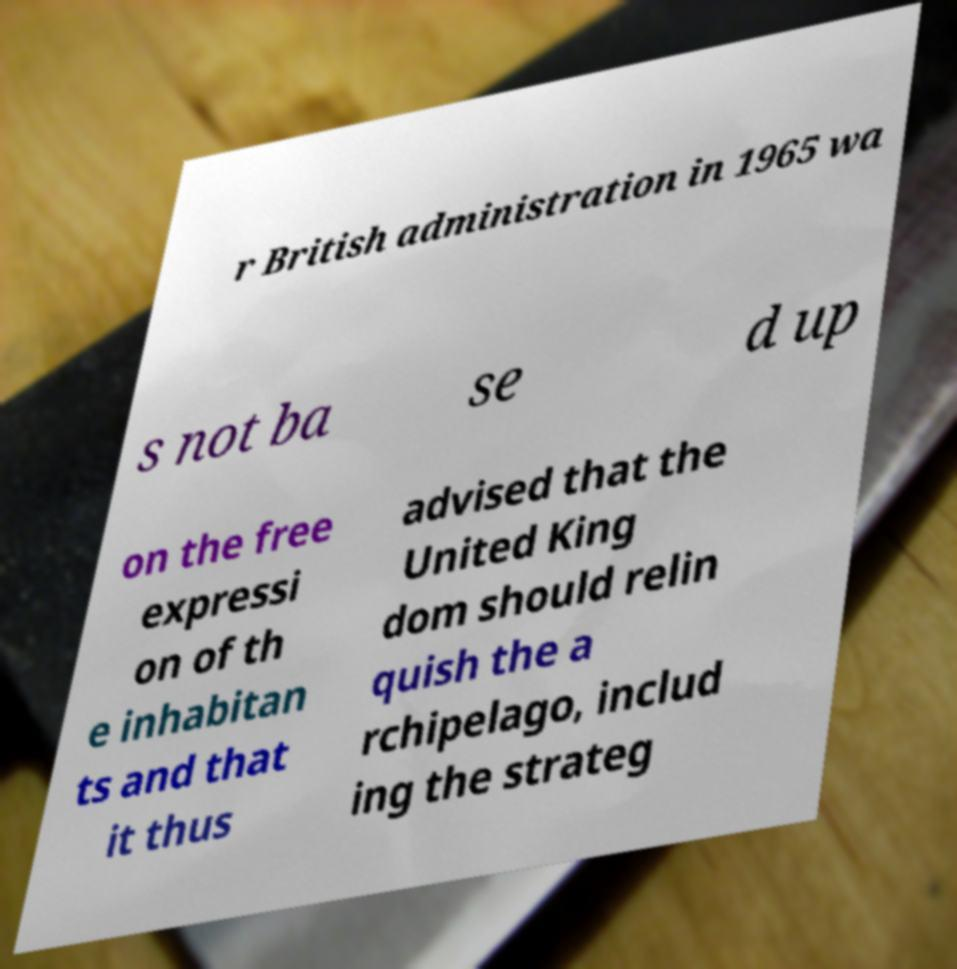Could you assist in decoding the text presented in this image and type it out clearly? r British administration in 1965 wa s not ba se d up on the free expressi on of th e inhabitan ts and that it thus advised that the United King dom should relin quish the a rchipelago, includ ing the strateg 